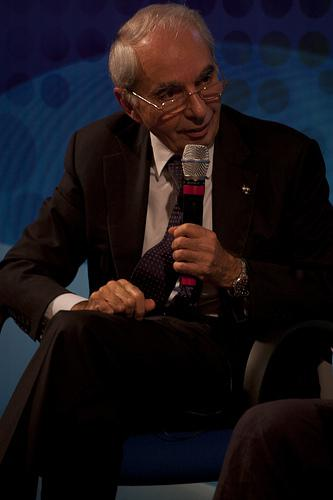Question: what is the color of the man's hair?
Choices:
A. Grey.
B. Black.
C. Blonde.
D. Red.
Answer with the letter. Answer: A Question: how is the microphone positioned?
Choices:
A. Downward.
B. Sideways.
C. Upright.
D. Crooked.
Answer with the letter. Answer: C Question: where is the man looking?
Choices:
A. To the left.
B. To the front.
C. To the back.
D. To the right.
Answer with the letter. Answer: D Question: where is the man's glasses?
Choices:
A. On the desk.
B. In his pocket.
C. Beside the table.
D. On his face.
Answer with the letter. Answer: D Question: what kind of print is on the man's tie?
Choices:
A. Polka dot.
B. Checkerboard.
C. Stripes.
D. Plaid.
Answer with the letter. Answer: A 